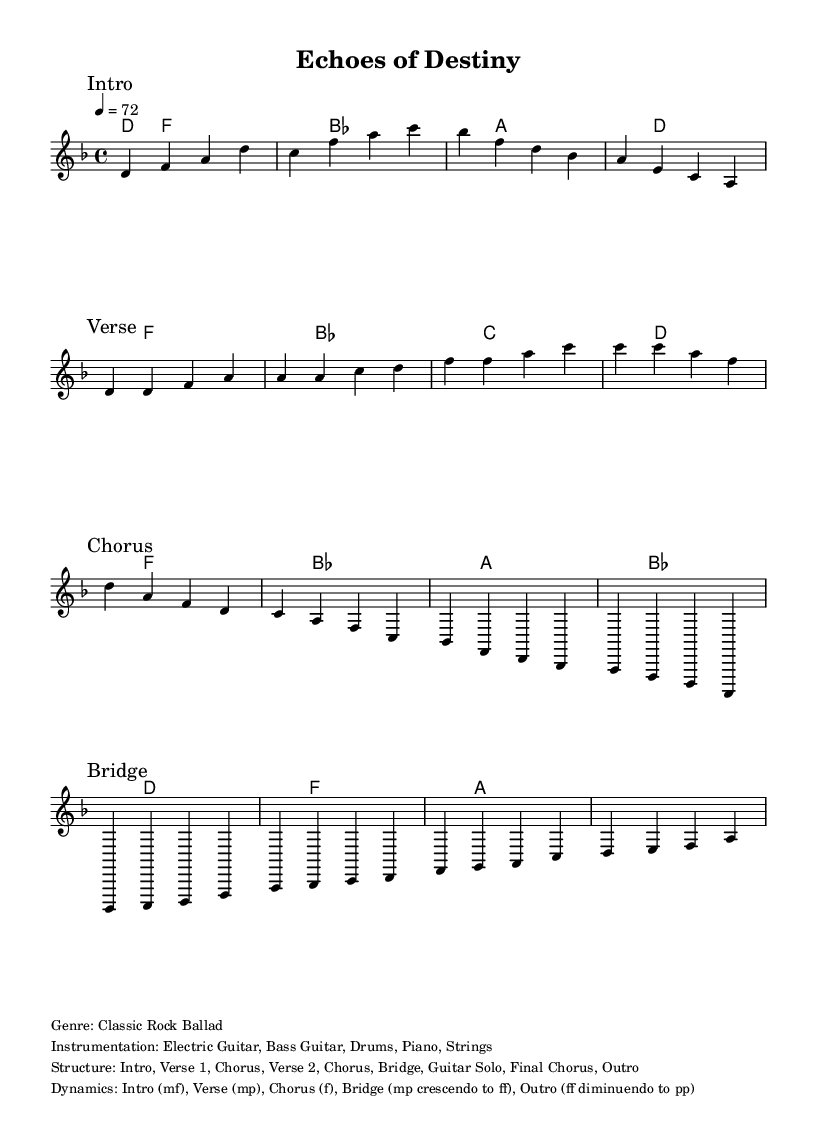What is the key signature of this music? The key signature is D minor, indicated by the presence of one flat (B flat). This can be identified in the global settings of the sheet music where it states "\key d \minor".
Answer: D minor What is the time signature of this piece? The time signature is 4/4, meaning there are four beats in a measure and the quarter note gets one beat. This is specified in the global section of the sheet music with "\time 4/4".
Answer: 4/4 What is the tempo marking of this composition? The tempo marking is 72 beats per minute, noted as "4 = 72" in the global section. This indicates the speed at which the piece should be played.
Answer: 72 How many sections does the structure of the song have? The structure of the song includes nine distinct sections: Intro, Verse 1, Chorus, Verse 2, Chorus, Bridge, Guitar Solo, Final Chorus, and Outro. This is outlined in the markup section of the sheet music.
Answer: Nine What dynamics are indicated for the bridge section? The dynamics for the bridge section indicate a transition from mezzo-piano (mp) to fortissimo (ff), meaning it starts softly and crescendos to very loud. This is specified in the dynamics section of the markup.
Answer: mp crescendo to ff Which instruments are part of the instrumentation? The instrumentation consists of Electric Guitar, Bass Guitar, Drums, Piano, and Strings, as detailed in the markup section.
Answer: Electric Guitar, Bass Guitar, Drums, Piano, Strings What type of song is this classified as? This song is classified as a Classic Rock Ballad, as stated in the genre line of the markup section.
Answer: Classic Rock Ballad 